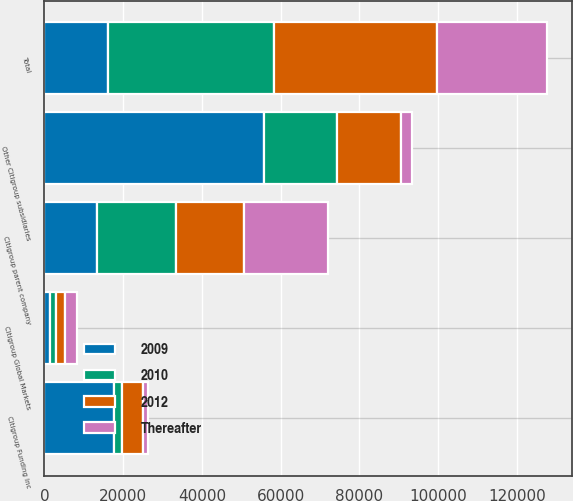Convert chart to OTSL. <chart><loc_0><loc_0><loc_500><loc_500><stacked_bar_chart><ecel><fcel>Citigroup parent company<fcel>Other Citigroup subsidiaries<fcel>Citigroup Global Markets<fcel>Citigroup Funding Inc<fcel>Total<nl><fcel>2009<fcel>13463<fcel>55853<fcel>1524<fcel>17632<fcel>16198<nl><fcel>2012<fcel>17500<fcel>16198<fcel>2352<fcel>5381<fcel>41431<nl><fcel>2010<fcel>19864<fcel>18607<fcel>1487<fcel>2154<fcel>42112<nl><fcel>Thereafter<fcel>21135<fcel>2718<fcel>2893<fcel>1253<fcel>27999<nl></chart> 